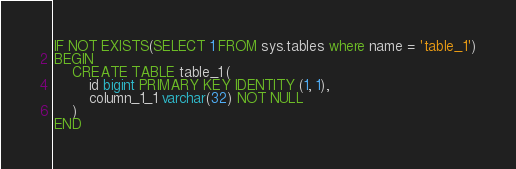<code> <loc_0><loc_0><loc_500><loc_500><_SQL_>IF NOT EXISTS(SELECT 1 FROM sys.tables where name = 'table_1')
BEGIN
    CREATE TABLE table_1 (
        id bigint PRIMARY KEY IDENTITY (1, 1),
        column_1_1 varchar(32) NOT NULL
    )
END


</code> 